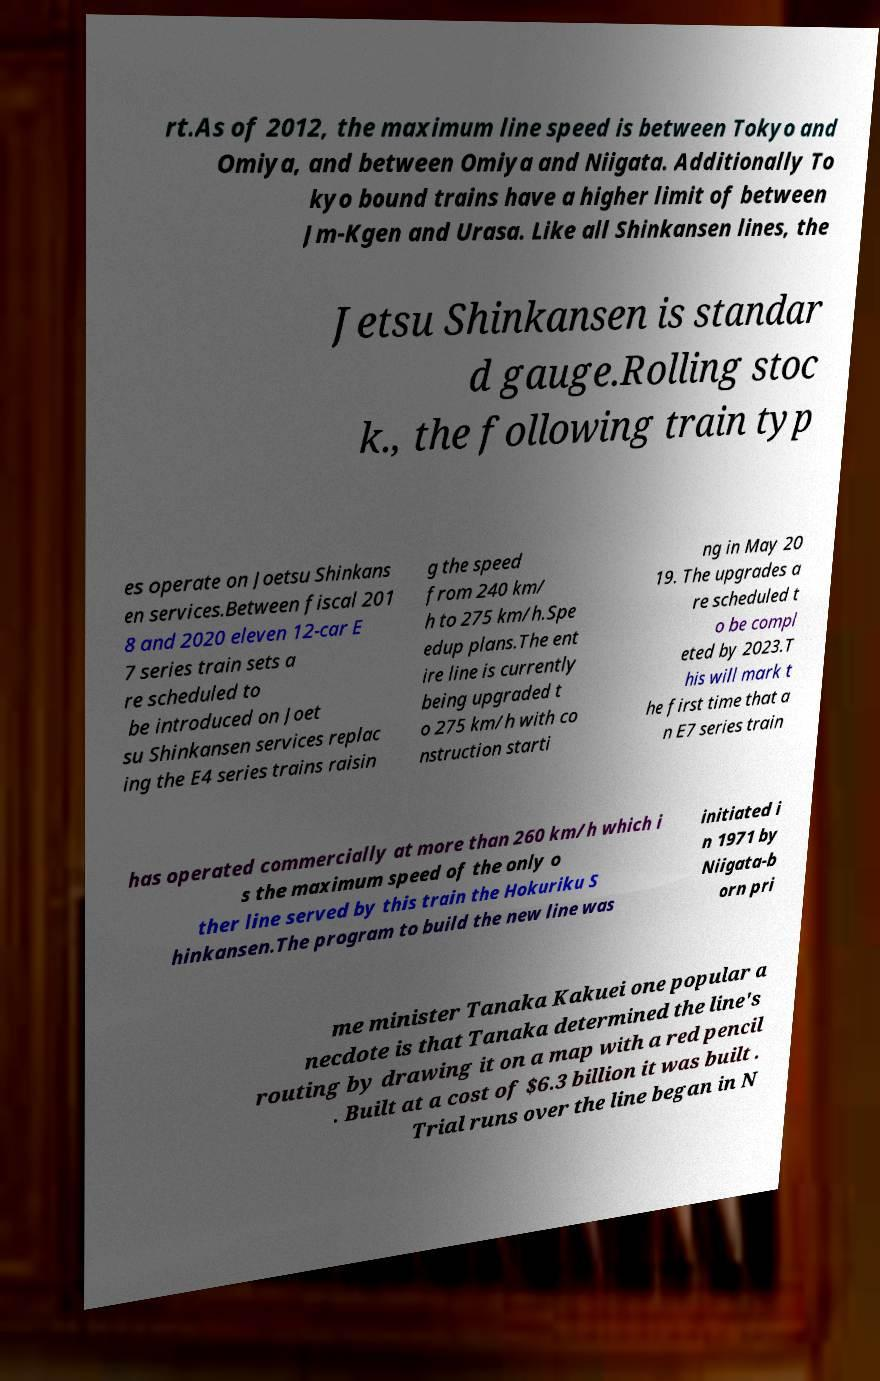Could you assist in decoding the text presented in this image and type it out clearly? rt.As of 2012, the maximum line speed is between Tokyo and Omiya, and between Omiya and Niigata. Additionally To kyo bound trains have a higher limit of between Jm-Kgen and Urasa. Like all Shinkansen lines, the Jetsu Shinkansen is standar d gauge.Rolling stoc k., the following train typ es operate on Joetsu Shinkans en services.Between fiscal 201 8 and 2020 eleven 12-car E 7 series train sets a re scheduled to be introduced on Joet su Shinkansen services replac ing the E4 series trains raisin g the speed from 240 km/ h to 275 km/h.Spe edup plans.The ent ire line is currently being upgraded t o 275 km/h with co nstruction starti ng in May 20 19. The upgrades a re scheduled t o be compl eted by 2023.T his will mark t he first time that a n E7 series train has operated commercially at more than 260 km/h which i s the maximum speed of the only o ther line served by this train the Hokuriku S hinkansen.The program to build the new line was initiated i n 1971 by Niigata-b orn pri me minister Tanaka Kakuei one popular a necdote is that Tanaka determined the line's routing by drawing it on a map with a red pencil . Built at a cost of $6.3 billion it was built . Trial runs over the line began in N 